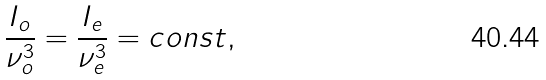<formula> <loc_0><loc_0><loc_500><loc_500>\frac { I _ { o } } { \nu _ { o } ^ { 3 } } = \frac { I _ { e } } { \nu _ { e } ^ { 3 } } = c o n s t ,</formula> 